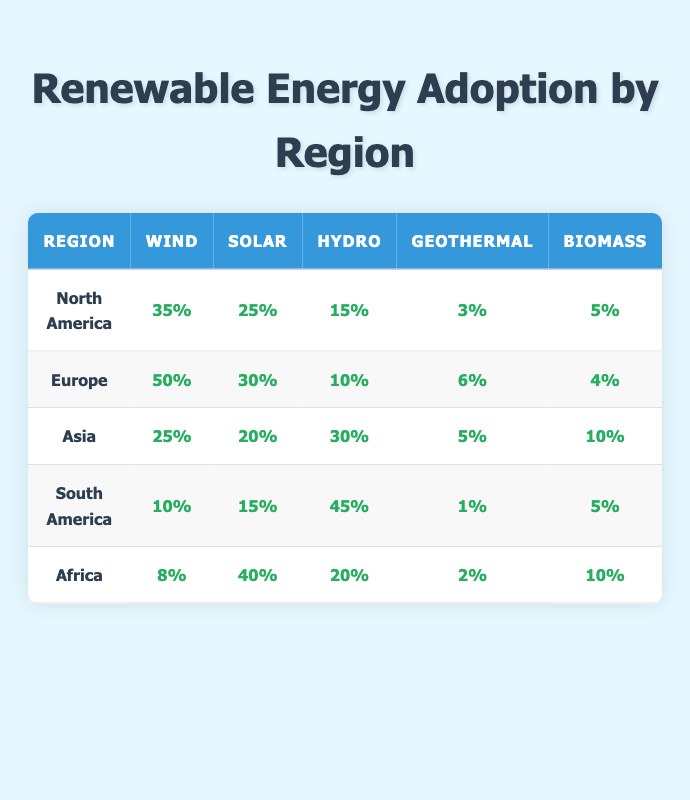What is the adoption rate of Solar energy in Europe? The table shows that the adoption rate of Solar energy in Europe is clearly indicated as 30%.
Answer: 30% Which region has the highest adoption rate for Wind energy? By comparing the Wind adoption rates in each region, Europe has the highest at 50%, while others have lower values.
Answer: Europe Is the adoption rate of Hydro energy in South America greater than that in Africa? In the table, the Hydro adoption rate is 45% for South America and 20% for Africa, showing that South America has a higher rate.
Answer: Yes What is the average adoption rate of Biomass across all regions? To find the average, add the Biomass rates: (5 + 4 + 10 + 5 + 10) = 34; since there are 5 regions, the average is 34/5 = 6.8.
Answer: 6.8 Which renewable source has the lowest adoption rate in North America? The table indicates that Geothermal has the lowest adoption rate in North America at 3%.
Answer: Geothermal Is it true that Asia has a higher adoption rate of Hydro energy compared to North America? Comparing the Hydro adoption rates in the table, Asia is at 30% while North America is at 15%, which confirms that Asia has a higher rate.
Answer: Yes Calculate the sum of adoption rates for all renewable sources in Europe. Adding the adoption rates for all sources in Europe: (50 + 30 + 10 + 6 + 4) = 100.
Answer: 100 In which region is Geothermal energy most adopted? The table shows that Europe leads in Geothermal energy adoption with a rate of 6%.
Answer: Europe What is the total adoption rate of Wind and Solar energy in Asia? Adding the rates for Wind (25%) and Solar (20%) gives a total of 45% for Asia.
Answer: 45% 